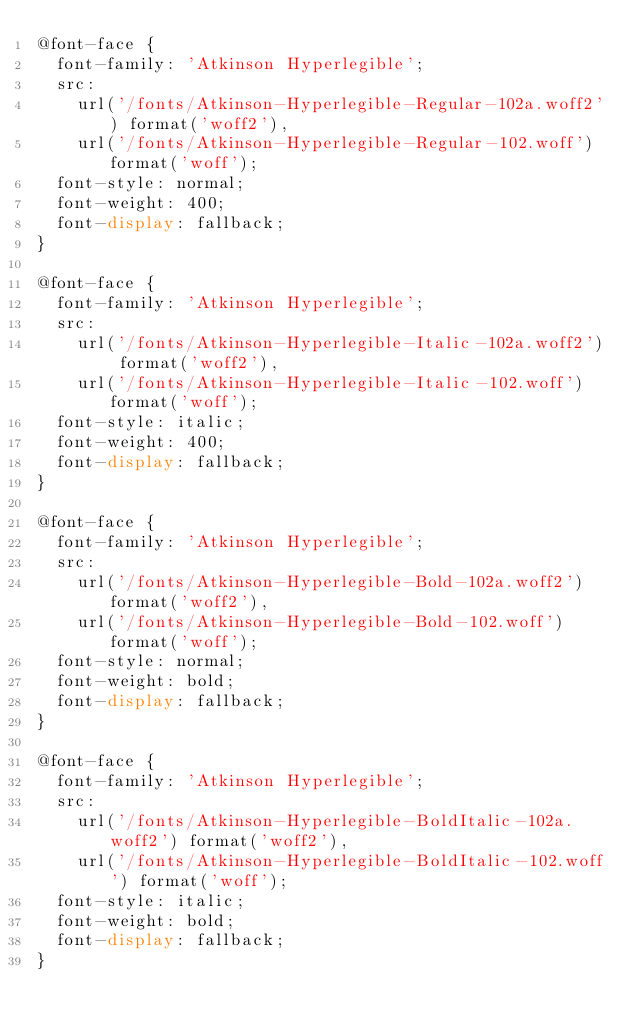<code> <loc_0><loc_0><loc_500><loc_500><_CSS_>@font-face {
	font-family: 'Atkinson Hyperlegible';
	src:
		url('/fonts/Atkinson-Hyperlegible-Regular-102a.woff2') format('woff2'),
		url('/fonts/Atkinson-Hyperlegible-Regular-102.woff') format('woff');
	font-style: normal;
	font-weight: 400;
	font-display: fallback;
}

@font-face {
	font-family: 'Atkinson Hyperlegible';
	src:
		url('/fonts/Atkinson-Hyperlegible-Italic-102a.woff2') format('woff2'),
		url('/fonts/Atkinson-Hyperlegible-Italic-102.woff') format('woff');
	font-style: italic;
	font-weight: 400;
	font-display: fallback;
}

@font-face {
	font-family: 'Atkinson Hyperlegible';
	src:
		url('/fonts/Atkinson-Hyperlegible-Bold-102a.woff2') format('woff2'),
		url('/fonts/Atkinson-Hyperlegible-Bold-102.woff') format('woff');
	font-style: normal;
	font-weight: bold;
	font-display: fallback;
}

@font-face {
	font-family: 'Atkinson Hyperlegible';
	src:
		url('/fonts/Atkinson-Hyperlegible-BoldItalic-102a.woff2') format('woff2'),
		url('/fonts/Atkinson-Hyperlegible-BoldItalic-102.woff') format('woff');
	font-style: italic;
	font-weight: bold;
	font-display: fallback;
}
</code> 